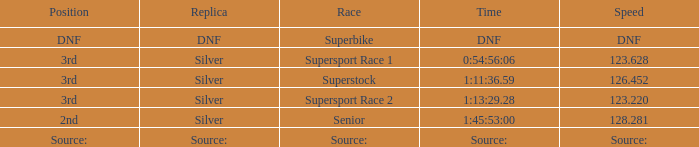Which race has a replica of DNF? Superbike. 